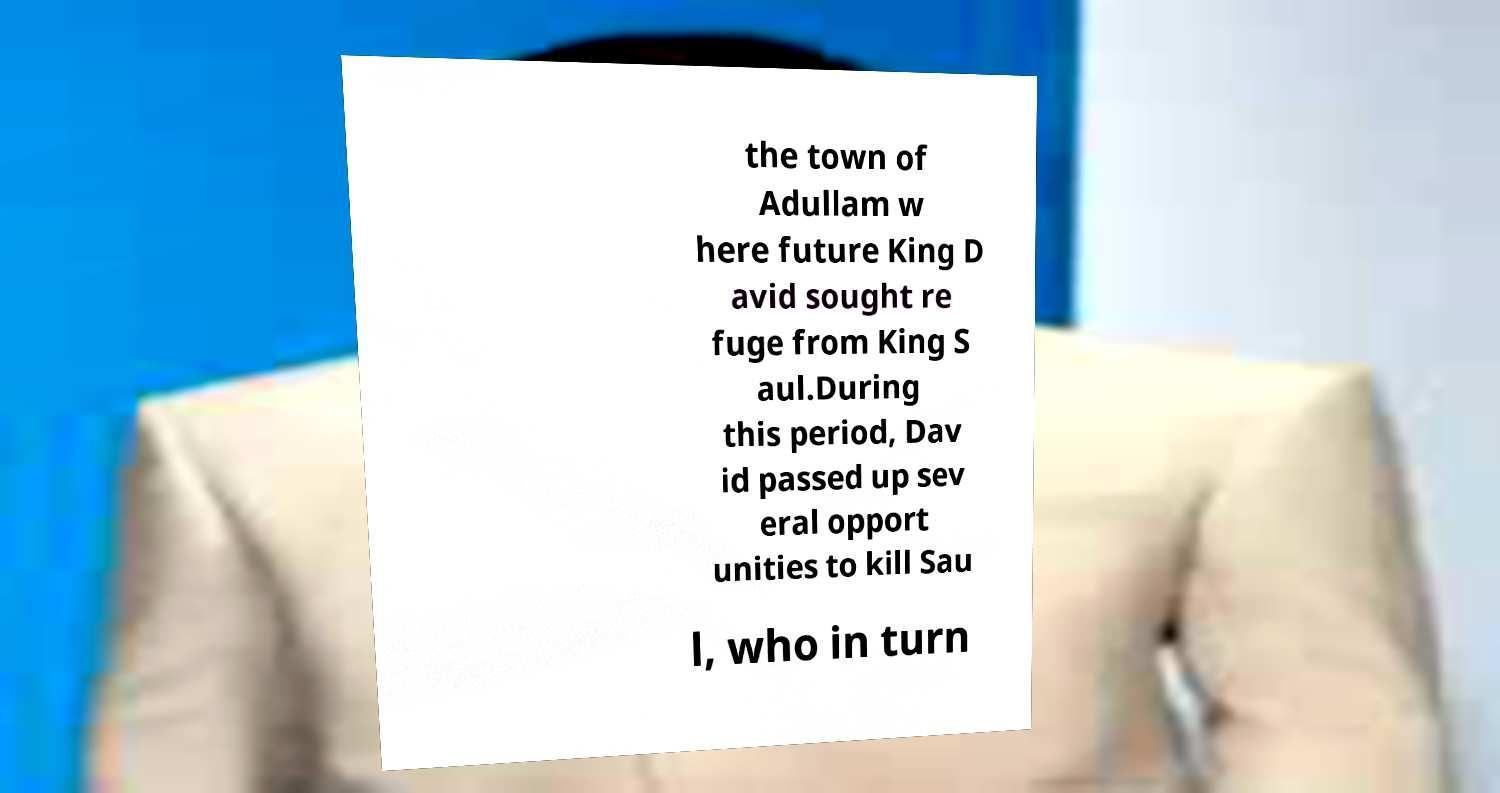Please read and relay the text visible in this image. What does it say? the town of Adullam w here future King D avid sought re fuge from King S aul.During this period, Dav id passed up sev eral opport unities to kill Sau l, who in turn 